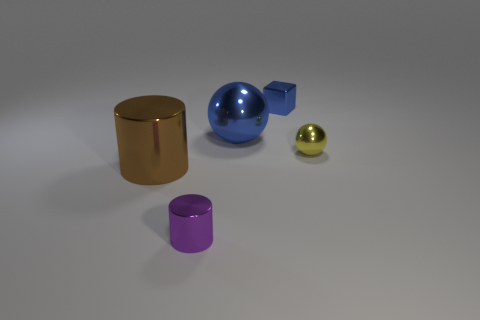What shape is the shiny thing that is behind the small purple object and in front of the small yellow object?
Your response must be concise. Cylinder. Are there any yellow things in front of the yellow sphere?
Offer a very short reply. No. Is there any other thing that is the same shape as the small blue object?
Provide a succinct answer. No. Do the tiny yellow metallic object and the large blue metal object have the same shape?
Give a very brief answer. Yes. Are there an equal number of tiny metal blocks that are behind the blue metal cube and big spheres that are in front of the brown thing?
Make the answer very short. Yes. What number of other objects are there of the same material as the brown object?
Keep it short and to the point. 4. How many tiny things are either metallic cubes or purple cylinders?
Keep it short and to the point. 2. Are there an equal number of big metallic cylinders that are to the right of the small purple metal cylinder and tiny purple things?
Your answer should be compact. No. Are there any tiny metallic things that are in front of the big blue sphere that is left of the tiny yellow object?
Ensure brevity in your answer.  Yes. What number of other things are there of the same color as the tiny metal cylinder?
Your answer should be very brief. 0. 